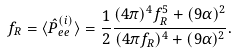<formula> <loc_0><loc_0><loc_500><loc_500>f _ { R } = \langle \hat { P } _ { e e } ^ { ( i ) } \rangle = \frac { 1 } { 2 } \frac { ( 4 \pi ) ^ { 4 } f _ { R } ^ { 5 } + ( 9 \alpha ) ^ { 2 } } { ( 4 \pi f _ { R } ) ^ { 4 } + ( 9 \alpha ) ^ { 2 } } .</formula> 